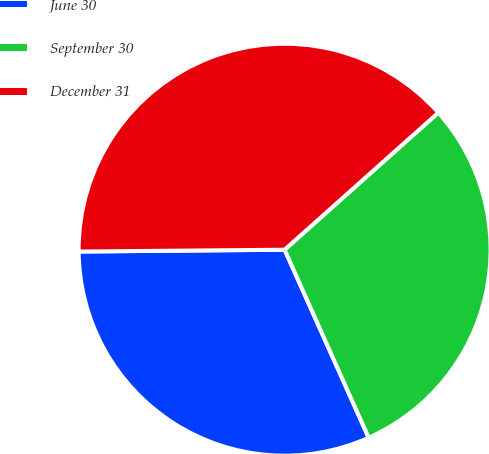Convert chart. <chart><loc_0><loc_0><loc_500><loc_500><pie_chart><fcel>June 30<fcel>September 30<fcel>December 31<nl><fcel>31.55%<fcel>29.9%<fcel>38.55%<nl></chart> 